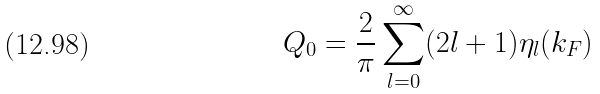Convert formula to latex. <formula><loc_0><loc_0><loc_500><loc_500>Q _ { 0 } = \frac { 2 } { \pi } \sum _ { l = 0 } ^ { \infty } ( 2 l + 1 ) \eta _ { l } ( k _ { F } )</formula> 